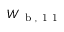Convert formula to latex. <formula><loc_0><loc_0><loc_500><loc_500>W _ { b , 1 1 }</formula> 